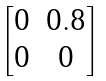Convert formula to latex. <formula><loc_0><loc_0><loc_500><loc_500>\begin{bmatrix} 0 & 0 . 8 \\ 0 & 0 \end{bmatrix}</formula> 